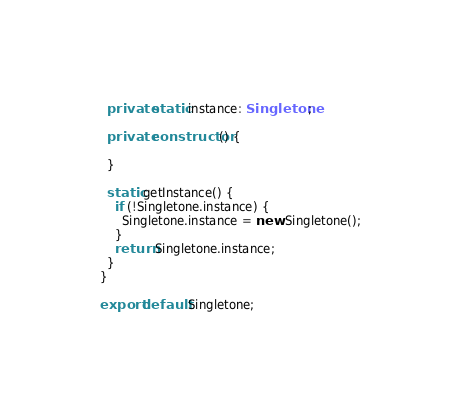Convert code to text. <code><loc_0><loc_0><loc_500><loc_500><_TypeScript_>  private static instance: Singletone;

  private constructor() {

  }

  static getInstance() {
    if (!Singletone.instance) {
      Singletone.instance = new Singletone();
    }
    return Singletone.instance;
  }
}

export default Singletone;</code> 